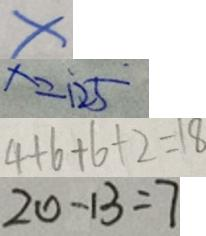<formula> <loc_0><loc_0><loc_500><loc_500>x 
 x = 1 2 5 
 4 + 6 + 6 + 2 = 1 8 
 2 0 - 1 3 = 7</formula> 